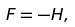Convert formula to latex. <formula><loc_0><loc_0><loc_500><loc_500>F = - H ,</formula> 